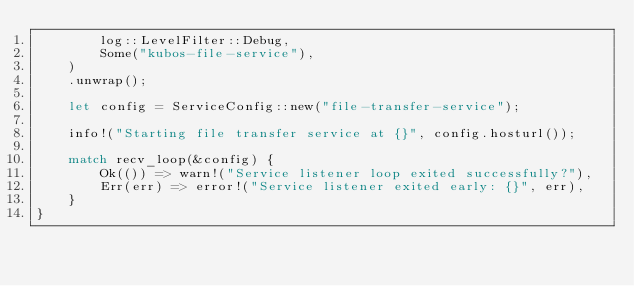Convert code to text. <code><loc_0><loc_0><loc_500><loc_500><_Rust_>        log::LevelFilter::Debug,
        Some("kubos-file-service"),
    )
    .unwrap();

    let config = ServiceConfig::new("file-transfer-service");

    info!("Starting file transfer service at {}", config.hosturl());

    match recv_loop(&config) {
        Ok(()) => warn!("Service listener loop exited successfully?"),
        Err(err) => error!("Service listener exited early: {}", err),
    }
}
</code> 